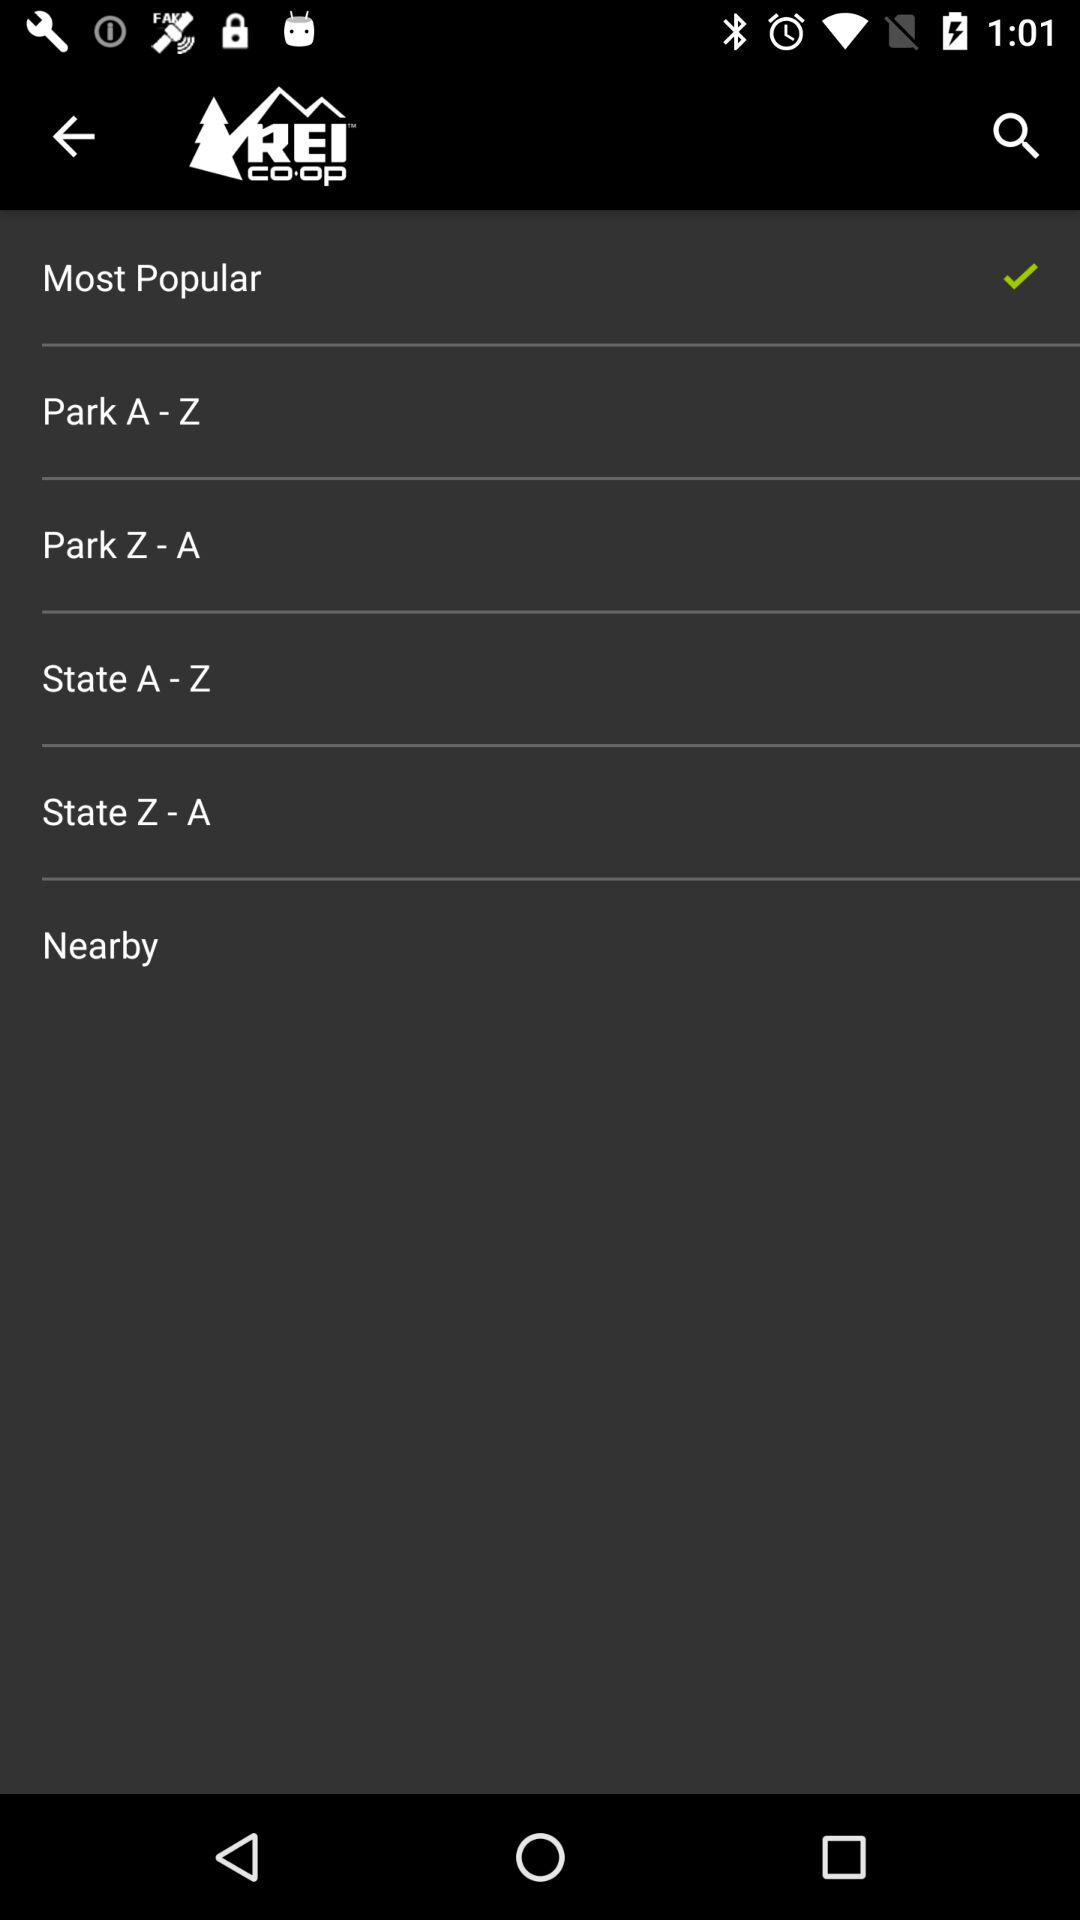What is the name of the application? The name of the application is "REI Co-op – Shop Outdoor Gear". 